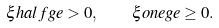Convert formula to latex. <formula><loc_0><loc_0><loc_500><loc_500>\xi h a l f g e > 0 , \quad \xi o n e g e \geq 0 .</formula> 